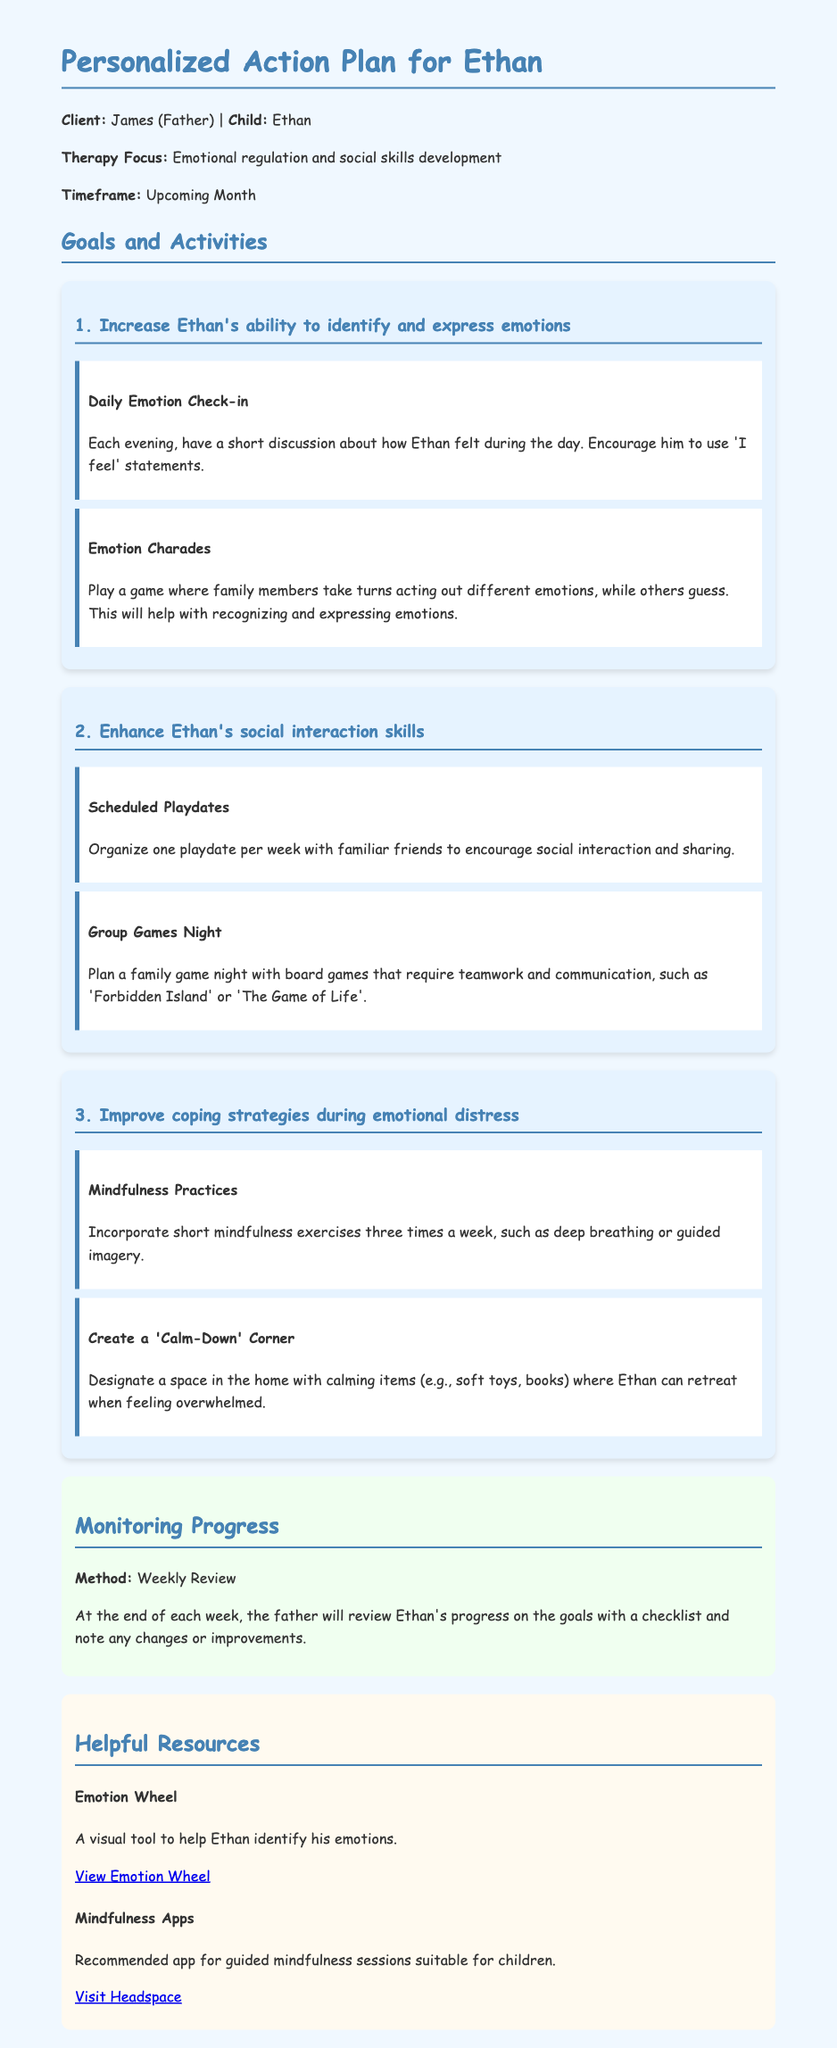What is the child's name? The child's name is mentioned in the introduction section of the document.
Answer: Ethan What is the therapy focus? The therapy focus is highlighted in the introductory paragraph of the document.
Answer: Emotional regulation and social skills development How often should the daily emotion check-in be conducted? The daily emotion check-in activity specifies the frequency of the activity.
Answer: Each evening What is one of the activities to improve social interaction skills? The document lists specific activities under each goal, one of which pertains to social interaction.
Answer: Scheduled playdates How many playdates are suggested per week? The number of playdates is specified in the relevant activity.
Answer: One What is the method for monitoring progress? The document states how progress should be monitored in the monitoring section.
Answer: Weekly Review What resource can help Ethan identify his emotions? The document lists specific resources available to assist Ethan, including one for identifying emotions.
Answer: Emotion Wheel What mindfulness practice is suggested? The document provides examples of mindfulness practices to be incorporated into the schedule.
Answer: Deep breathing What is a key component of the calm-down corner? The calm-down corner is described in the relevant activity section, specifying its content or features.
Answer: Calming items 